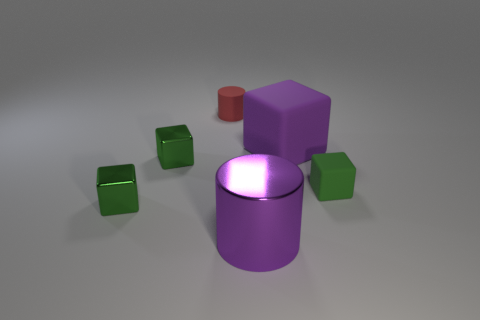How many small red rubber cylinders are there?
Ensure brevity in your answer.  1. How many cubes are both in front of the big purple rubber block and on the left side of the green rubber thing?
Make the answer very short. 2. What is the material of the big cylinder?
Provide a succinct answer. Metal. Are any small red things visible?
Offer a terse response. Yes. There is a cylinder on the right side of the red rubber cylinder; what color is it?
Offer a terse response. Purple. What number of small red things are right of the matte block that is behind the tiny green cube that is right of the purple matte object?
Offer a very short reply. 0. What material is the cube that is behind the small green rubber cube and left of the tiny red cylinder?
Give a very brief answer. Metal. Is the red thing made of the same material as the green cube to the right of the tiny rubber cylinder?
Offer a very short reply. Yes. Is the number of green things to the left of the green matte cube greater than the number of green blocks behind the purple rubber object?
Provide a succinct answer. Yes. The red thing has what shape?
Provide a short and direct response. Cylinder. 